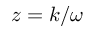Convert formula to latex. <formula><loc_0><loc_0><loc_500><loc_500>z = k / \omega</formula> 